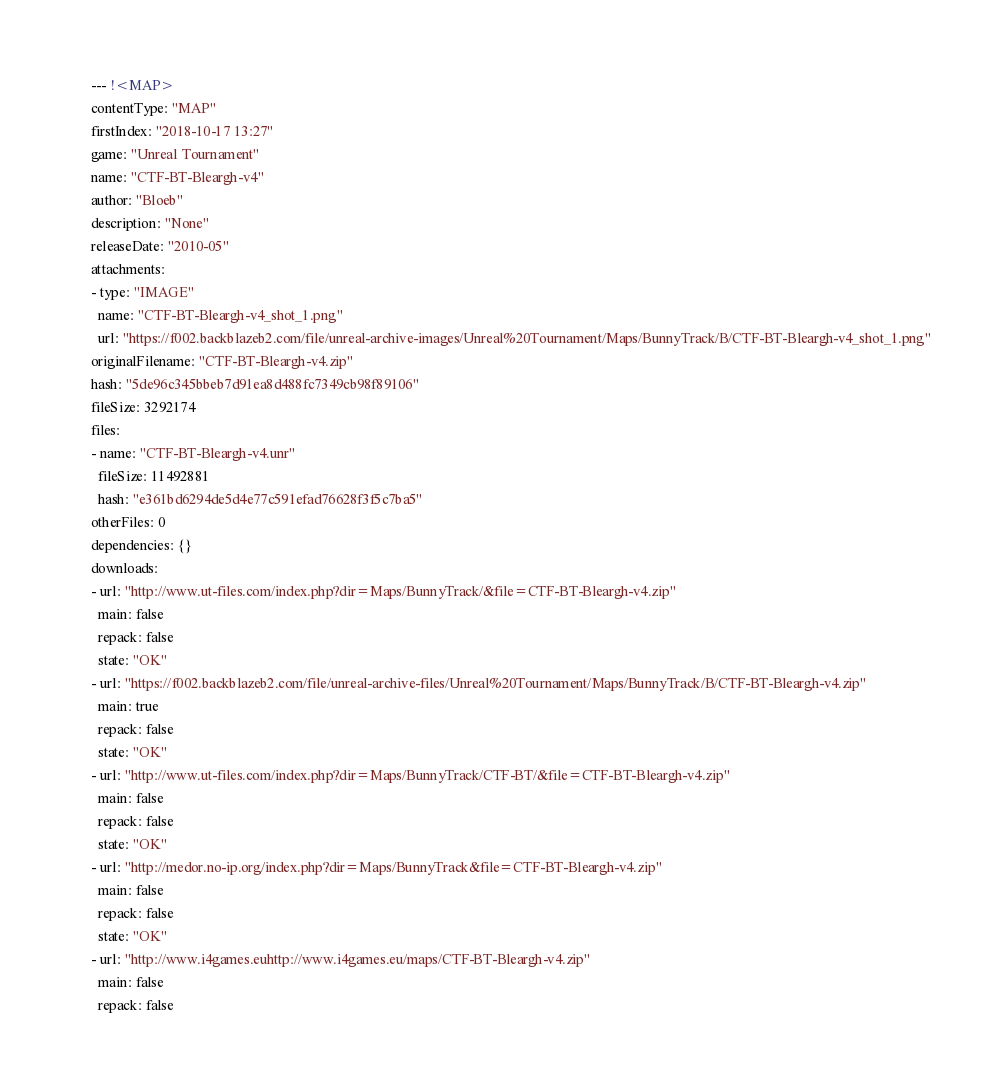<code> <loc_0><loc_0><loc_500><loc_500><_YAML_>--- !<MAP>
contentType: "MAP"
firstIndex: "2018-10-17 13:27"
game: "Unreal Tournament"
name: "CTF-BT-Bleargh-v4"
author: "Bloeb"
description: "None"
releaseDate: "2010-05"
attachments:
- type: "IMAGE"
  name: "CTF-BT-Bleargh-v4_shot_1.png"
  url: "https://f002.backblazeb2.com/file/unreal-archive-images/Unreal%20Tournament/Maps/BunnyTrack/B/CTF-BT-Bleargh-v4_shot_1.png"
originalFilename: "CTF-BT-Bleargh-v4.zip"
hash: "5de96c345bbeb7d91ea8d488fc7349cb98f89106"
fileSize: 3292174
files:
- name: "CTF-BT-Bleargh-v4.unr"
  fileSize: 11492881
  hash: "e361bd6294de5d4e77c591efad76628f3f5c7ba5"
otherFiles: 0
dependencies: {}
downloads:
- url: "http://www.ut-files.com/index.php?dir=Maps/BunnyTrack/&file=CTF-BT-Bleargh-v4.zip"
  main: false
  repack: false
  state: "OK"
- url: "https://f002.backblazeb2.com/file/unreal-archive-files/Unreal%20Tournament/Maps/BunnyTrack/B/CTF-BT-Bleargh-v4.zip"
  main: true
  repack: false
  state: "OK"
- url: "http://www.ut-files.com/index.php?dir=Maps/BunnyTrack/CTF-BT/&file=CTF-BT-Bleargh-v4.zip"
  main: false
  repack: false
  state: "OK"
- url: "http://medor.no-ip.org/index.php?dir=Maps/BunnyTrack&file=CTF-BT-Bleargh-v4.zip"
  main: false
  repack: false
  state: "OK"
- url: "http://www.i4games.euhttp://www.i4games.eu/maps/CTF-BT-Bleargh-v4.zip"
  main: false
  repack: false</code> 